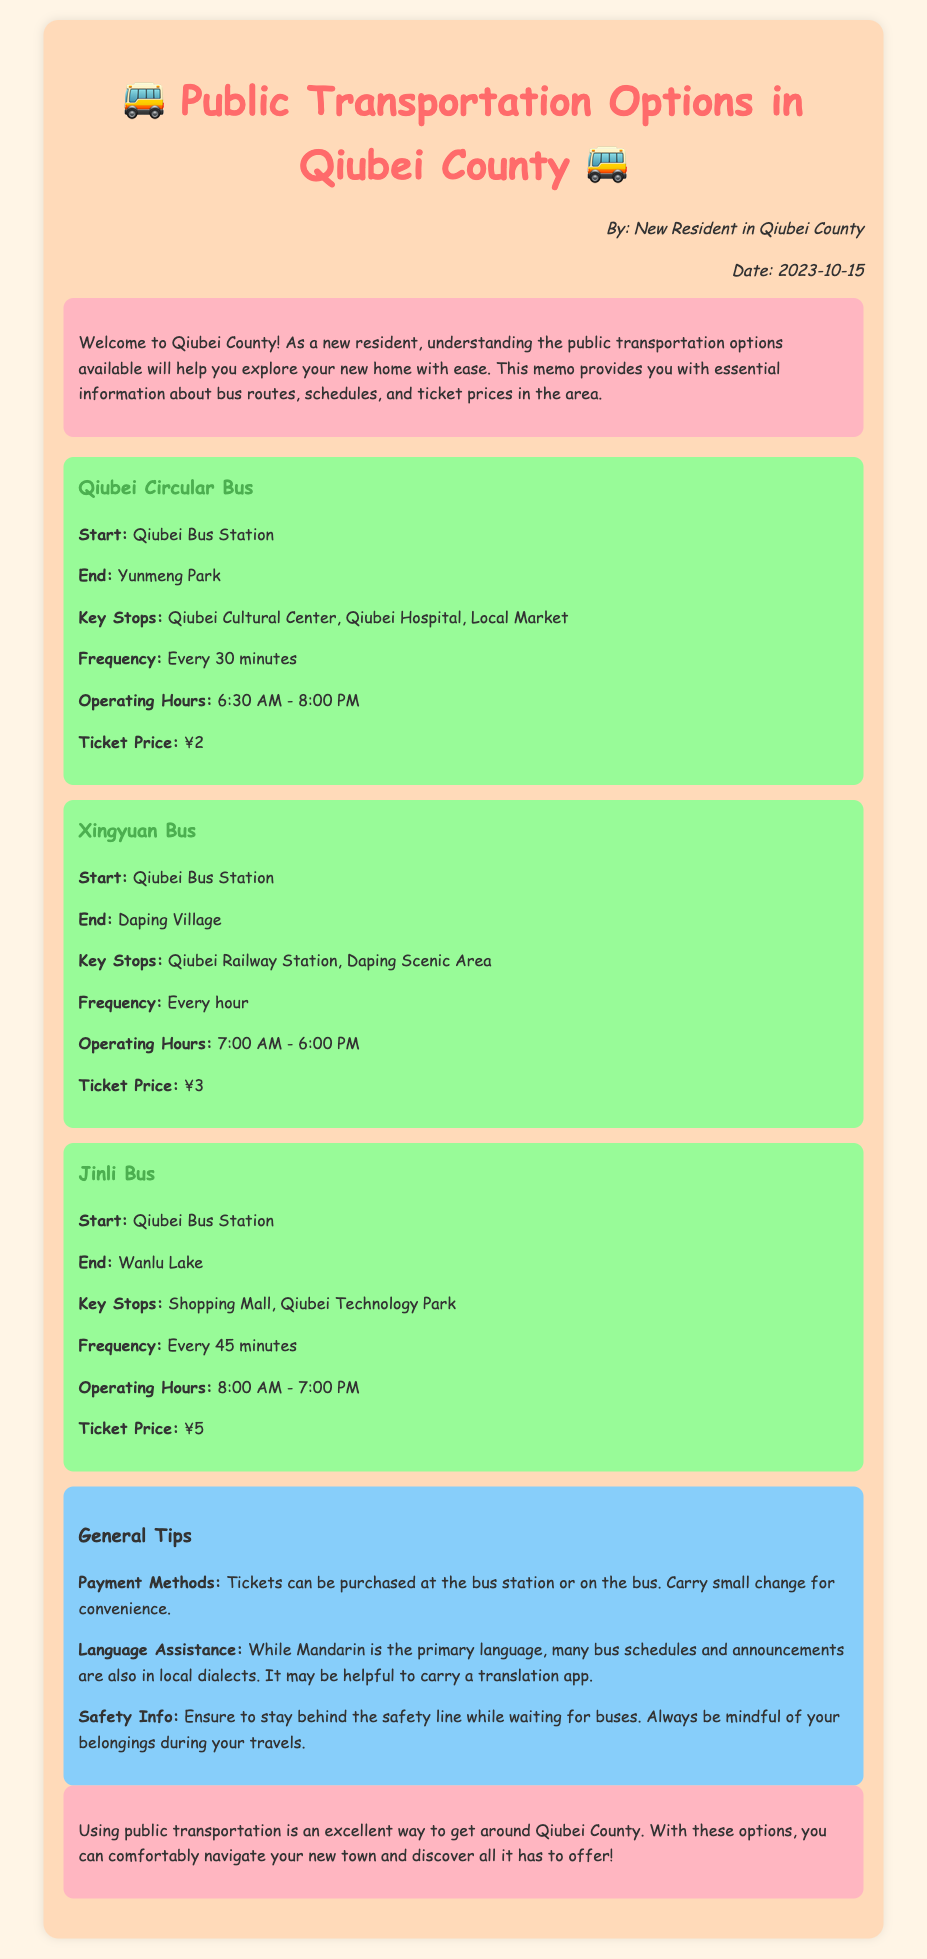What is the start point of the Qiubei Circular Bus? The start point is specifically mentioned in the document as "Qiubei Bus Station" for the Qiubei Circular Bus route.
Answer: Qiubei Bus Station What is the ticket price for the Jinli Bus? The ticket price is mentioned in the Jinli Bus section of the document.
Answer: ¥5 How often does the Xingyuan Bus run? The frequency of the Xingyuan Bus is described in the document as "Every hour."
Answer: Every hour What time does the Qiubei Circular Bus start operating? The operating hours for the Qiubei Circular Bus begin at a specified time in the document.
Answer: 6:30 AM What is a suggested payment method for bus tickets? The document recommends purchasing tickets at the bus station or on the bus, indicating a preferred payment method.
Answer: Small change What is one of the key stops for the Jinli Bus? The document lists key stops for the Jinli Bus, highlighting particular notable locations.
Answer: Shopping Mall Which route has the longest operating hours? This requires comparing the operating hours of different bus routes mentioned in the document to determine which one lasts the longest.
Answer: Jinli Bus What language is primarily used for bus schedules according to the document? The document specifies the main language used for bus communication and information.
Answer: Mandarin 